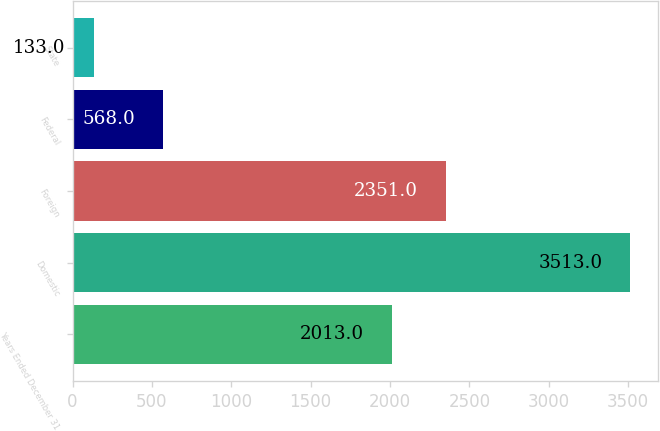Convert chart to OTSL. <chart><loc_0><loc_0><loc_500><loc_500><bar_chart><fcel>Years Ended December 31<fcel>Domestic<fcel>Foreign<fcel>Federal<fcel>State<nl><fcel>2013<fcel>3513<fcel>2351<fcel>568<fcel>133<nl></chart> 